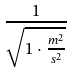<formula> <loc_0><loc_0><loc_500><loc_500>\frac { 1 } { \sqrt { 1 \cdot \frac { m ^ { 2 } } { s ^ { 2 } } } }</formula> 